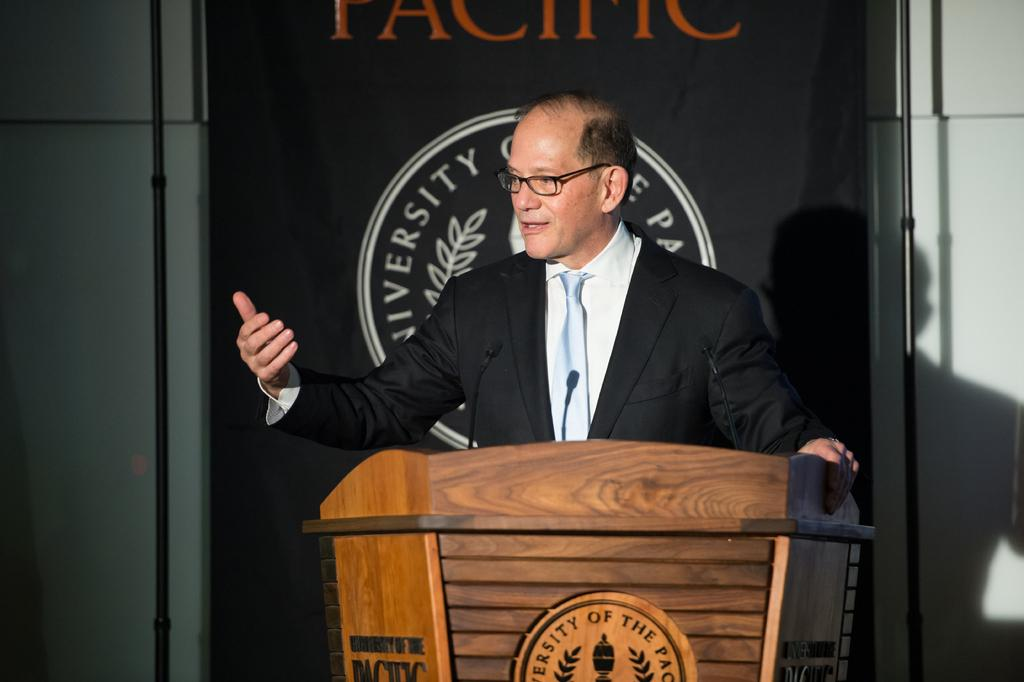What is the man in the image doing? The man is standing in the image. What is the man wearing in the image? The man is wearing a blazer. What object is in front of the man in the image? There is a podium in front of the man. What can be seen in the background of the image? There is a black banner in the background. What is on the black banner in the image? The banner has a logo on it. Can you tell me how many planes are flying in the image? There are no planes visible in the image. What is the man's interest in the image? The provided facts do not mention the man's interests, so we cannot determine his interest from the image. 